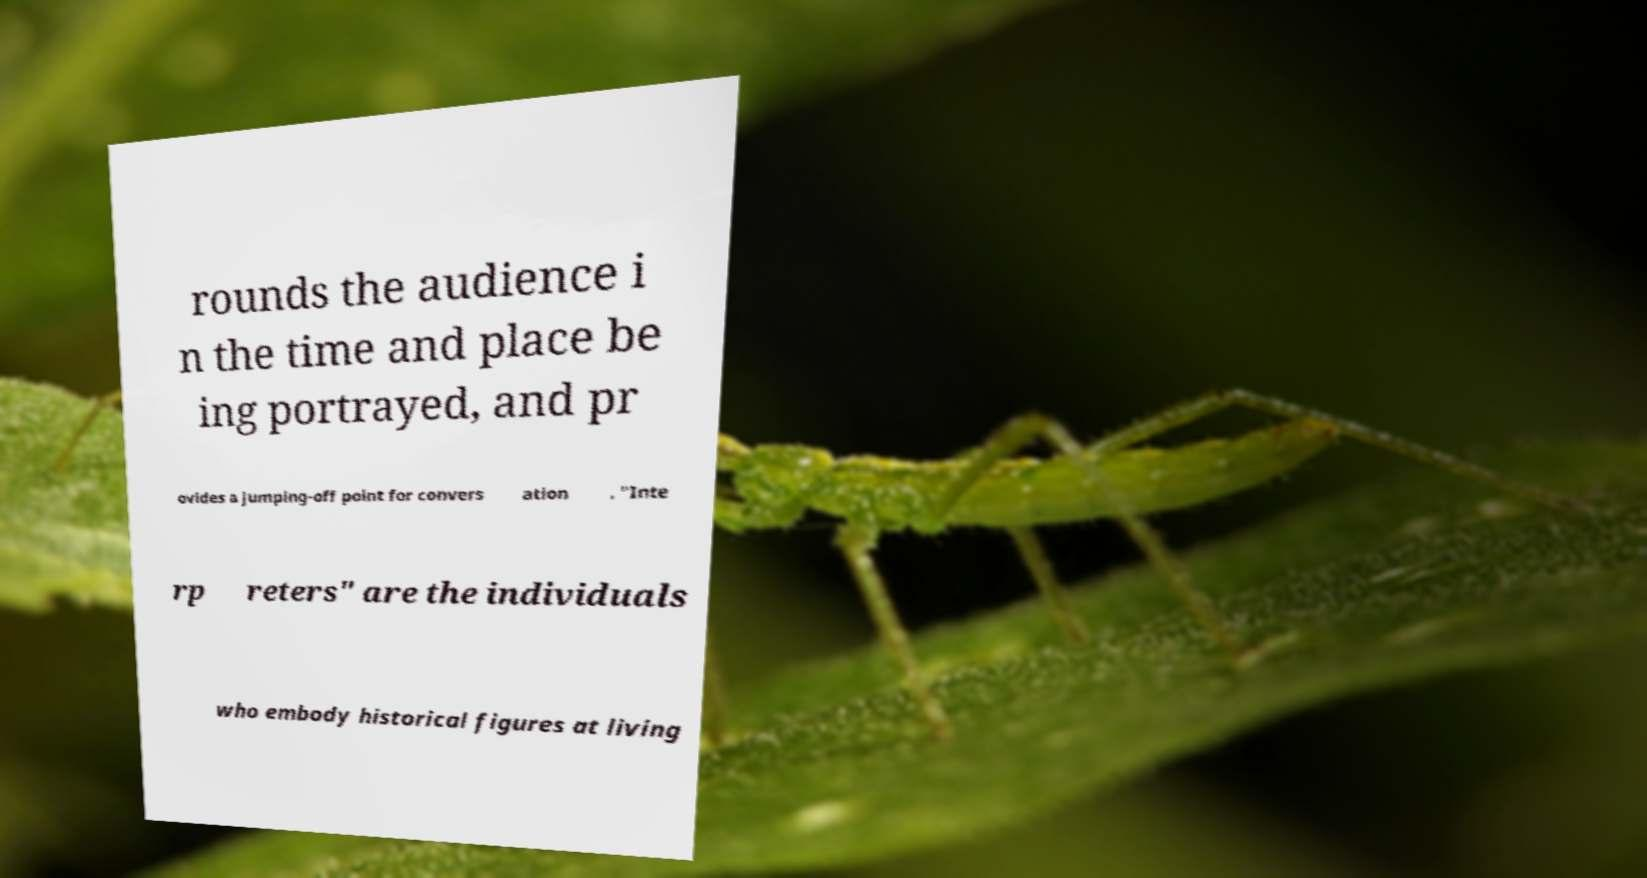Can you read and provide the text displayed in the image?This photo seems to have some interesting text. Can you extract and type it out for me? rounds the audience i n the time and place be ing portrayed, and pr ovides a jumping-off point for convers ation . "Inte rp reters" are the individuals who embody historical figures at living 